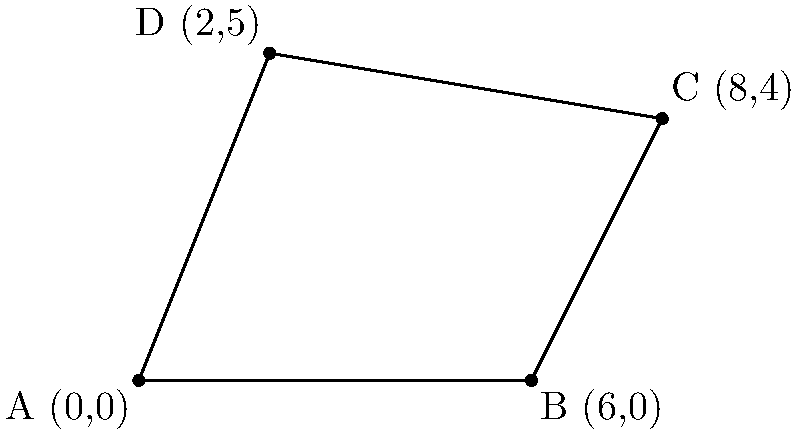As a travel writer exploring British fishing traditions, you've encountered an interesting problem related to an irregular-shaped fishing ground. The local fishermen have provided you with the coordinates of the area's boundaries: A(0,0), B(6,0), C(8,4), and D(2,5). Calculate the area of this fishing ground using coordinate geometry. How might this information enhance your blog post about traditional fishing practices and their connection to local geography? To calculate the area of this irregular quadrilateral fishing ground, we can use the Shoelace formula (also known as the surveyor's formula). This method is particularly useful for finding the area of a polygon given its vertices.

The steps to solve this problem are:

1) First, recall the Shoelace formula for a quadrilateral ABCD:

   Area = $\frac{1}{2}|x_Ay_B + x_By_C + x_Cy_D + x_Dy_A - x_By_A - x_Cy_B - x_Dy_C - x_Ay_D|$

2) Substitute the given coordinates:
   A(0,0), B(6,0), C(8,4), D(2,5)

3) Apply the formula:

   Area = $\frac{1}{2}|(0 \cdot 0 + 6 \cdot 4 + 8 \cdot 5 + 2 \cdot 0) - (6 \cdot 0 + 8 \cdot 0 + 2 \cdot 4 + 0 \cdot 5)|$

4) Simplify:
   
   Area = $\frac{1}{2}|(0 + 24 + 40 + 0) - (0 + 0 + 8 + 0)|$
   
   Area = $\frac{1}{2}|64 - 8|$
   
   Area = $\frac{1}{2} \cdot 56$

5) Calculate the final result:
   
   Area = 28 square units

This calculation provides the exact area of the irregular fishing ground. In the context of your blog post, you could use this information to discuss how local fishermen have traditionally defined and measured their fishing grounds, linking it to the importance of geometry in practical, everyday situations. You might also explore how the shape and size of fishing grounds relate to local marine ecosystems and fishing regulations, adding depth to your narrative about British fishing history and practices.
Answer: 28 square units 